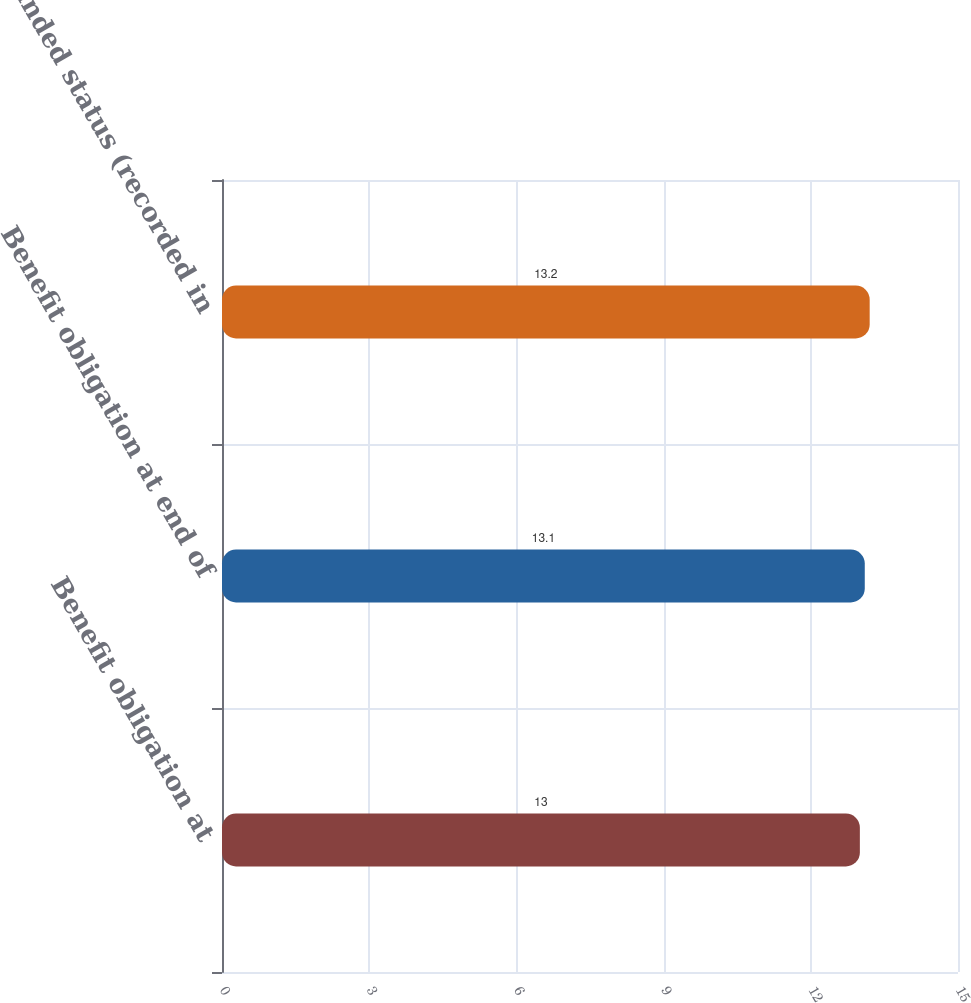Convert chart to OTSL. <chart><loc_0><loc_0><loc_500><loc_500><bar_chart><fcel>Benefit obligation at<fcel>Benefit obligation at end of<fcel>Funded status (recorded in<nl><fcel>13<fcel>13.1<fcel>13.2<nl></chart> 